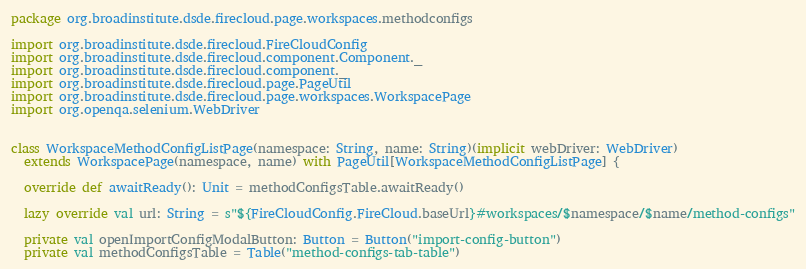<code> <loc_0><loc_0><loc_500><loc_500><_Scala_>package org.broadinstitute.dsde.firecloud.page.workspaces.methodconfigs

import org.broadinstitute.dsde.firecloud.FireCloudConfig
import org.broadinstitute.dsde.firecloud.component.Component._
import org.broadinstitute.dsde.firecloud.component._
import org.broadinstitute.dsde.firecloud.page.PageUtil
import org.broadinstitute.dsde.firecloud.page.workspaces.WorkspacePage
import org.openqa.selenium.WebDriver


class WorkspaceMethodConfigListPage(namespace: String, name: String)(implicit webDriver: WebDriver)
  extends WorkspacePage(namespace, name) with PageUtil[WorkspaceMethodConfigListPage] {

  override def awaitReady(): Unit = methodConfigsTable.awaitReady()

  lazy override val url: String = s"${FireCloudConfig.FireCloud.baseUrl}#workspaces/$namespace/$name/method-configs"

  private val openImportConfigModalButton: Button = Button("import-config-button")
  private val methodConfigsTable = Table("method-configs-tab-table")</code> 